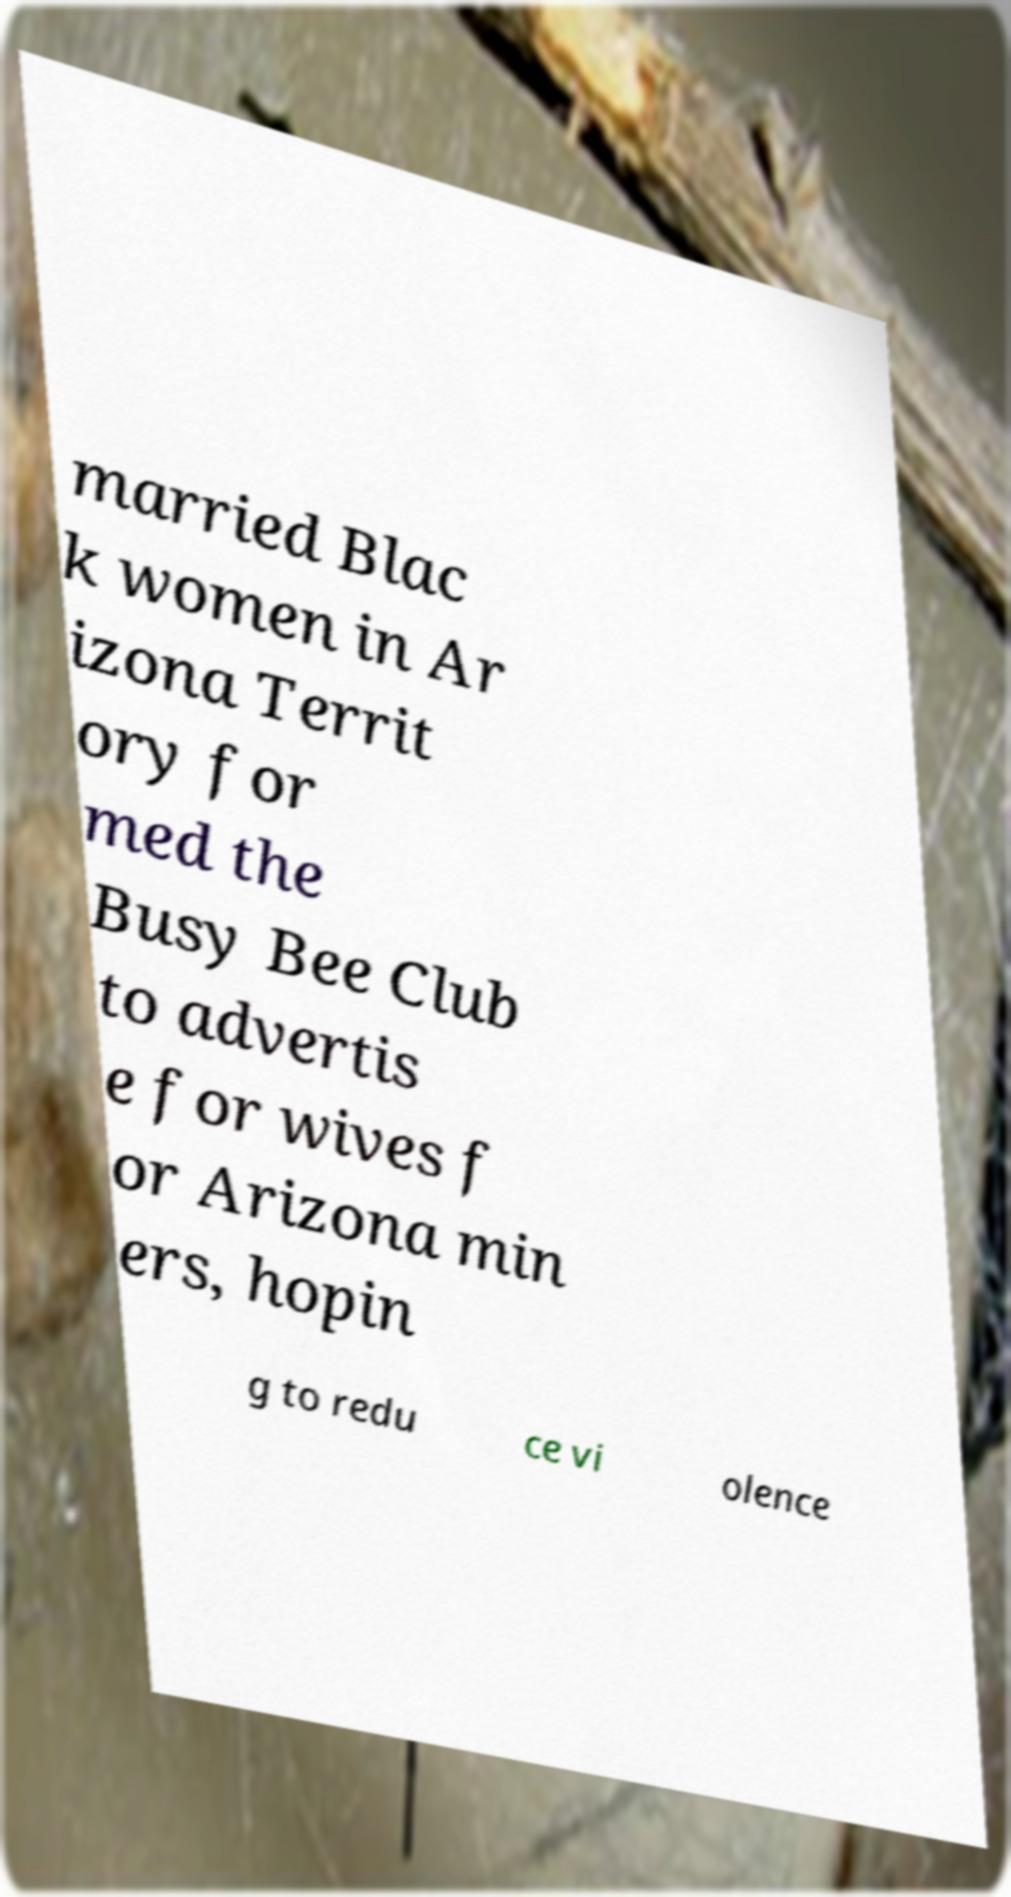Can you read and provide the text displayed in the image?This photo seems to have some interesting text. Can you extract and type it out for me? married Blac k women in Ar izona Territ ory for med the Busy Bee Club to advertis e for wives f or Arizona min ers, hopin g to redu ce vi olence 